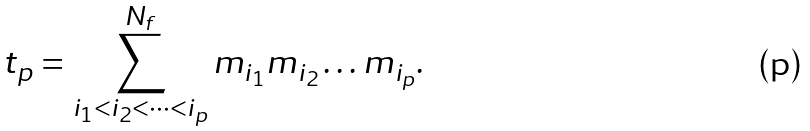Convert formula to latex. <formula><loc_0><loc_0><loc_500><loc_500>t _ { p } = \sum _ { i _ { 1 } < i _ { 2 } < \cdots < i _ { p } } ^ { N _ { f } } m _ { i _ { 1 } } m _ { i _ { 2 } } \dots m _ { i _ { p } } .</formula> 